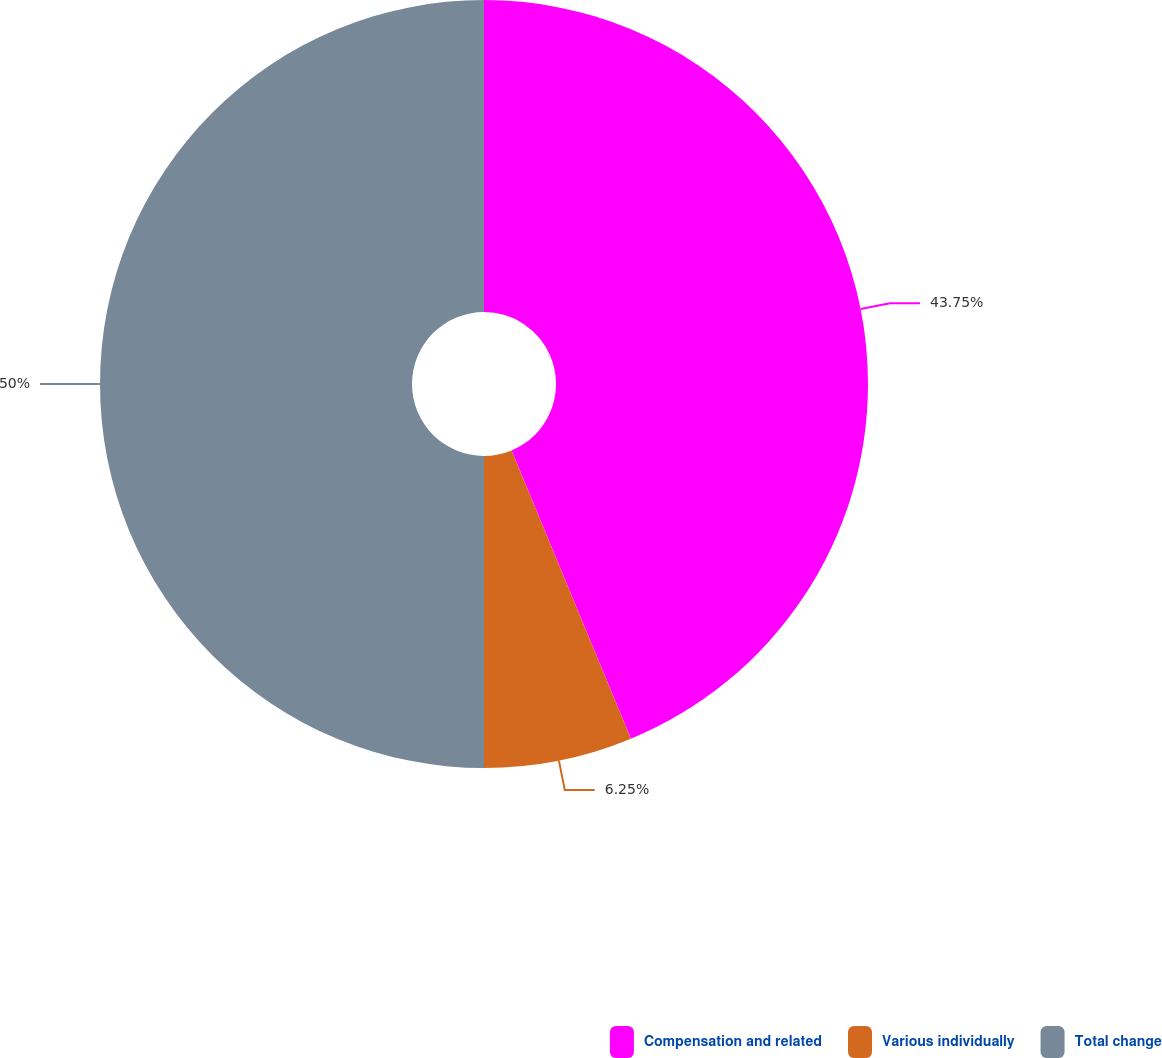<chart> <loc_0><loc_0><loc_500><loc_500><pie_chart><fcel>Compensation and related<fcel>Various individually<fcel>Total change<nl><fcel>43.75%<fcel>6.25%<fcel>50.0%<nl></chart> 